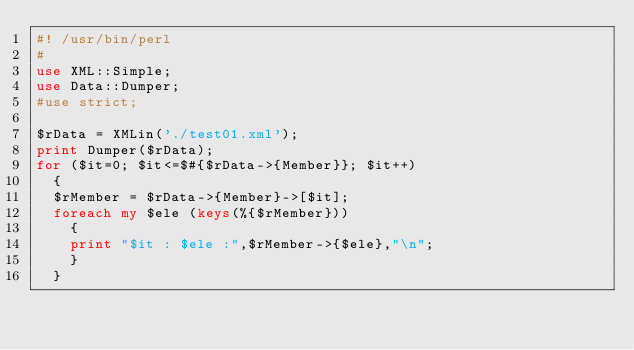Convert code to text. <code><loc_0><loc_0><loc_500><loc_500><_Perl_>#! /usr/bin/perl
#
use XML::Simple;
use Data::Dumper;
#use strict;

$rData = XMLin('./test01.xml');
print Dumper($rData);
for ($it=0; $it<=$#{$rData->{Member}}; $it++)
	{
	$rMember = $rData->{Member}->[$it];
	foreach my $ele (keys(%{$rMember}))
		{
		print "$it : $ele :",$rMember->{$ele},"\n";
		}
	}
</code> 